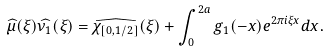<formula> <loc_0><loc_0><loc_500><loc_500>\widehat { \mu } ( \xi ) \widehat { \nu _ { 1 } } ( \xi ) = \widehat { \chi _ { [ 0 , 1 / 2 ] } } ( \xi ) + \int _ { 0 } ^ { 2 a } g _ { 1 } ( - x ) e ^ { 2 \pi i \xi x } d x .</formula> 